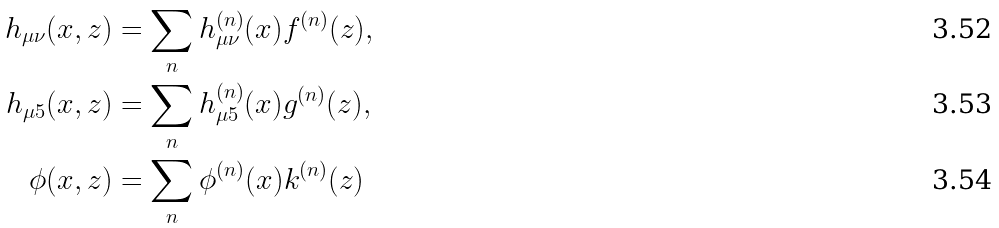<formula> <loc_0><loc_0><loc_500><loc_500>h _ { \mu \nu } ( x , z ) & = \sum _ { n } h _ { \mu \nu } ^ { ( n ) } ( x ) f ^ { ( n ) } ( z ) , \\ h _ { \mu 5 } ( x , z ) & = \sum _ { n } h _ { \mu 5 } ^ { ( n ) } ( x ) g ^ { ( n ) } ( z ) , \\ \phi ( x , z ) & = \sum _ { n } \phi ^ { ( n ) } ( x ) k ^ { ( n ) } ( z )</formula> 